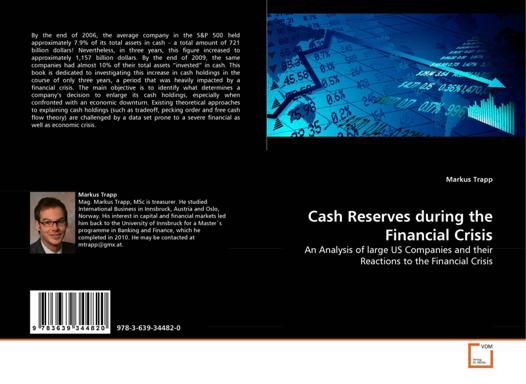What is the ISBN number of the book? The ISBN number of 'Cash Reserves during the Financial Crisis' is 978-3-639-34482-0. ISBNs are useful for identifying and ordering books, as each ISBN is unique to a specific book edition, making it an essential tool for libraries, booksellers, and readers. 